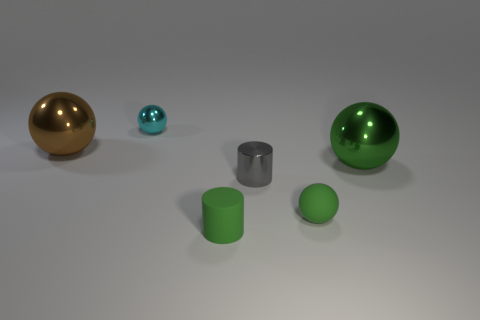The other ball that is the same color as the tiny matte sphere is what size?
Ensure brevity in your answer.  Large. What shape is the small metal object to the right of the tiny green thing that is to the left of the gray metallic cylinder?
Provide a short and direct response. Cylinder. Does the cyan thing have the same shape as the tiny metal thing in front of the cyan shiny sphere?
Provide a succinct answer. No. There is a metal thing that is the same size as the brown sphere; what color is it?
Ensure brevity in your answer.  Green. Is the number of green cylinders on the right side of the green rubber cylinder less than the number of big metal balls left of the brown metallic object?
Your answer should be compact. No. What shape is the big thing that is left of the large shiny sphere that is in front of the large ball left of the large green metallic ball?
Make the answer very short. Sphere. There is a shiny thing that is to the right of the tiny shiny cylinder; is its color the same as the tiny ball to the right of the tiny cyan metal sphere?
Keep it short and to the point. Yes. There is a large thing that is the same color as the matte sphere; what is its shape?
Give a very brief answer. Sphere. What number of shiny objects are either tiny spheres or large green objects?
Give a very brief answer. 2. The big metal object that is right of the rubber thing that is in front of the tiny green thing that is on the right side of the small gray metallic object is what color?
Offer a terse response. Green. 